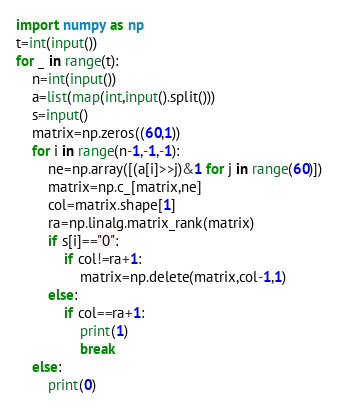Convert code to text. <code><loc_0><loc_0><loc_500><loc_500><_Python_>import numpy as np
t=int(input())
for _ in range(t):
    n=int(input())
    a=list(map(int,input().split()))
    s=input()
    matrix=np.zeros((60,1))
    for i in range(n-1,-1,-1):
        ne=np.array([(a[i]>>j)&1 for j in range(60)])
        matrix=np.c_[matrix,ne]
        col=matrix.shape[1]
        ra=np.linalg.matrix_rank(matrix)
        if s[i]=="0":
            if col!=ra+1:
                matrix=np.delete(matrix,col-1,1)
        else:
            if col==ra+1:
                print(1)
                break
    else:
        print(0)</code> 